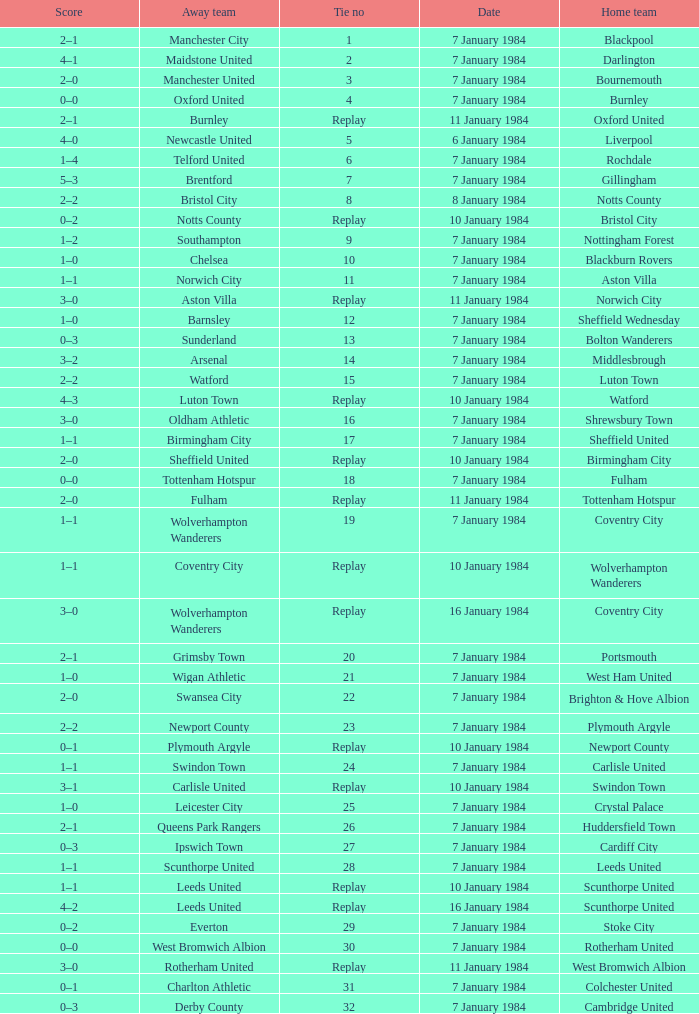Who was the away team with a tie of 14? Arsenal. 